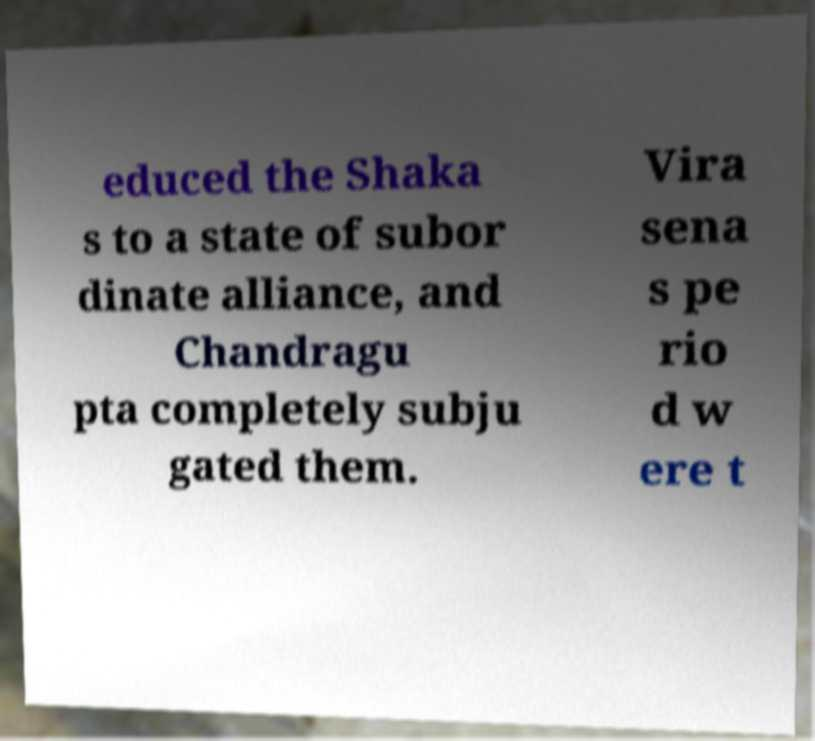Can you accurately transcribe the text from the provided image for me? educed the Shaka s to a state of subor dinate alliance, and Chandragu pta completely subju gated them. Vira sena s pe rio d w ere t 